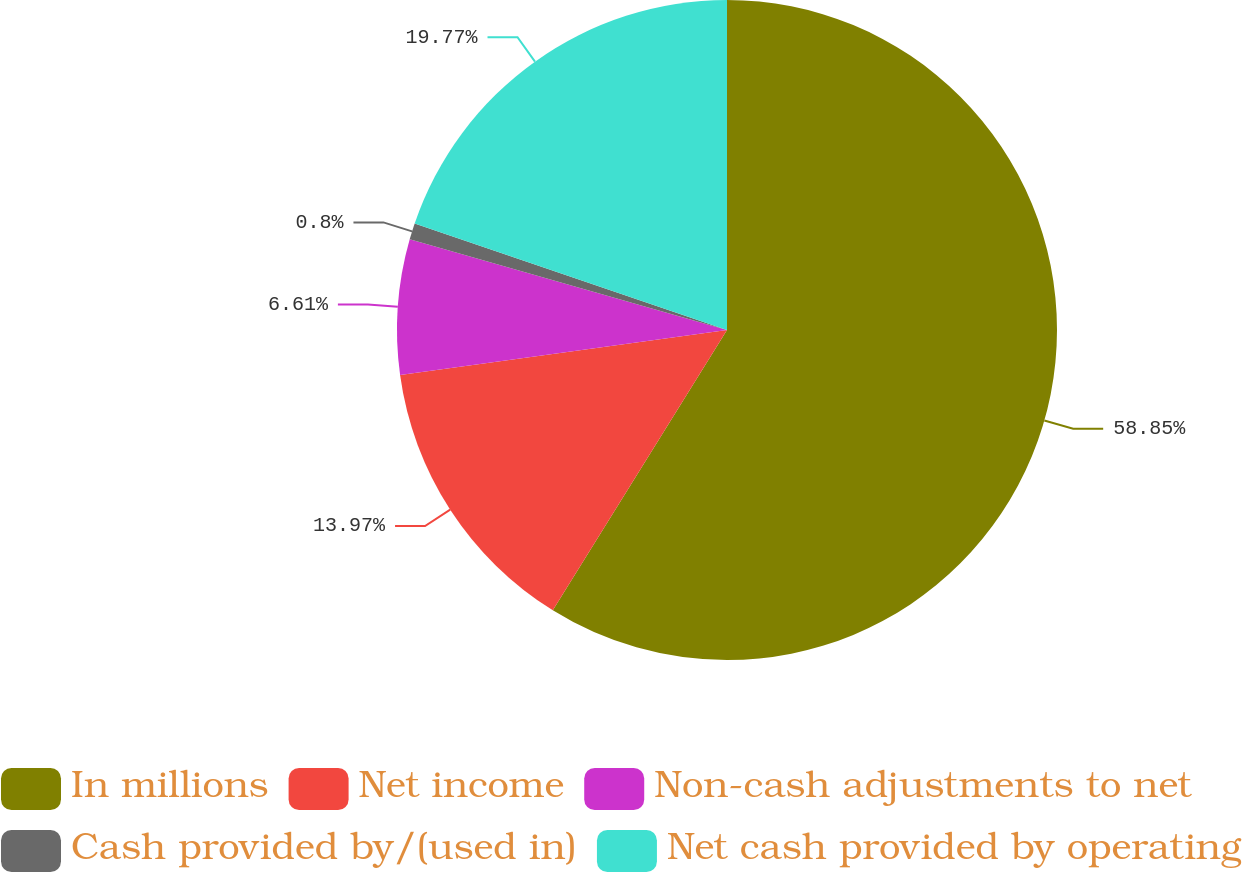<chart> <loc_0><loc_0><loc_500><loc_500><pie_chart><fcel>In millions<fcel>Net income<fcel>Non-cash adjustments to net<fcel>Cash provided by/(used in)<fcel>Net cash provided by operating<nl><fcel>58.85%<fcel>13.97%<fcel>6.61%<fcel>0.8%<fcel>19.77%<nl></chart> 